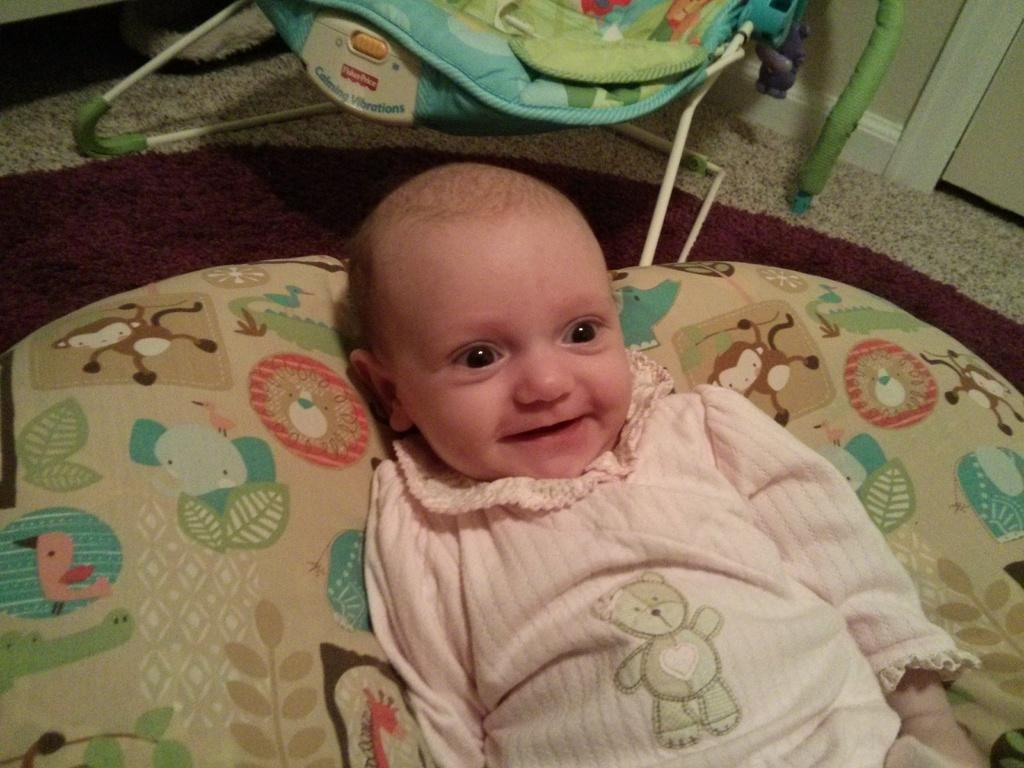What is the main subject of the image? There is a baby in the middle of the image. What is the baby doing in the image? The baby is smiling. What can be seen in the background of the image? There is a baby cart in the background of the image. What experience does the baby have in teaching others in the image? There is no indication in the image that the baby has any experience in teaching others. 